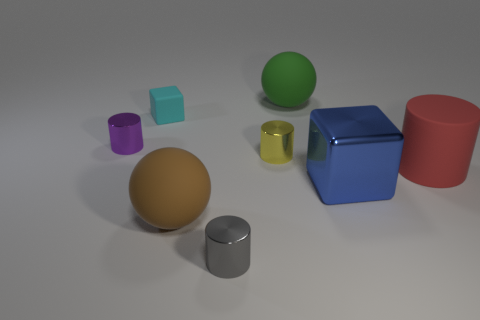Add 2 small yellow matte cubes. How many objects exist? 10 Subtract all cubes. How many objects are left? 6 Subtract all big green rubber things. Subtract all large metallic cylinders. How many objects are left? 7 Add 1 blue blocks. How many blue blocks are left? 2 Add 5 gray cylinders. How many gray cylinders exist? 6 Subtract 1 red cylinders. How many objects are left? 7 